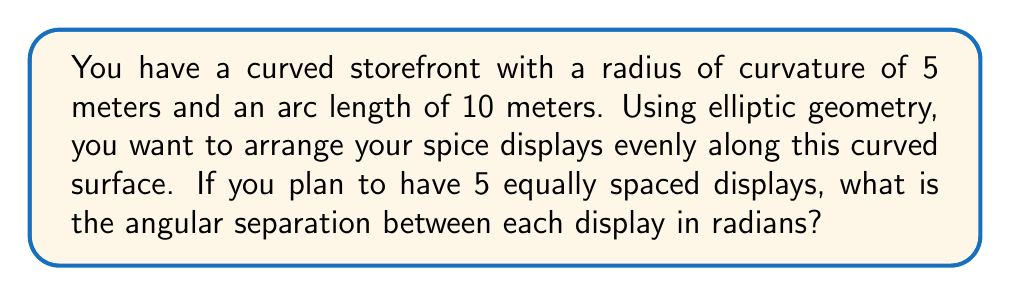Help me with this question. Let's approach this step-by-step using principles of elliptic geometry:

1) In elliptic geometry on a sphere, the relationship between arc length $s$, radius $r$, and central angle $\theta$ (in radians) is:

   $$s = r\theta$$

2) We're given:
   - Radius of curvature $r = 5$ meters
   - Total arc length $s = 10$ meters
   - Number of displays $n = 5$

3) First, let's find the total central angle $\theta_{total}$:

   $$\theta_{total} = \frac{s}{r} = \frac{10}{5} = 2$$ radians

4) Now, we need to divide this total angle by the number of spaces between displays. With 5 displays, there are 4 spaces:

   $$\theta_{separation} = \frac{\theta_{total}}{n-1} = \frac{2}{4} = \frac{1}{2}$$ radians

5) This $\frac{1}{2}$ radian (or $\frac{\pi}{4}$ radians) is the angular separation between each display.
Answer: $\frac{1}{2}$ radians 